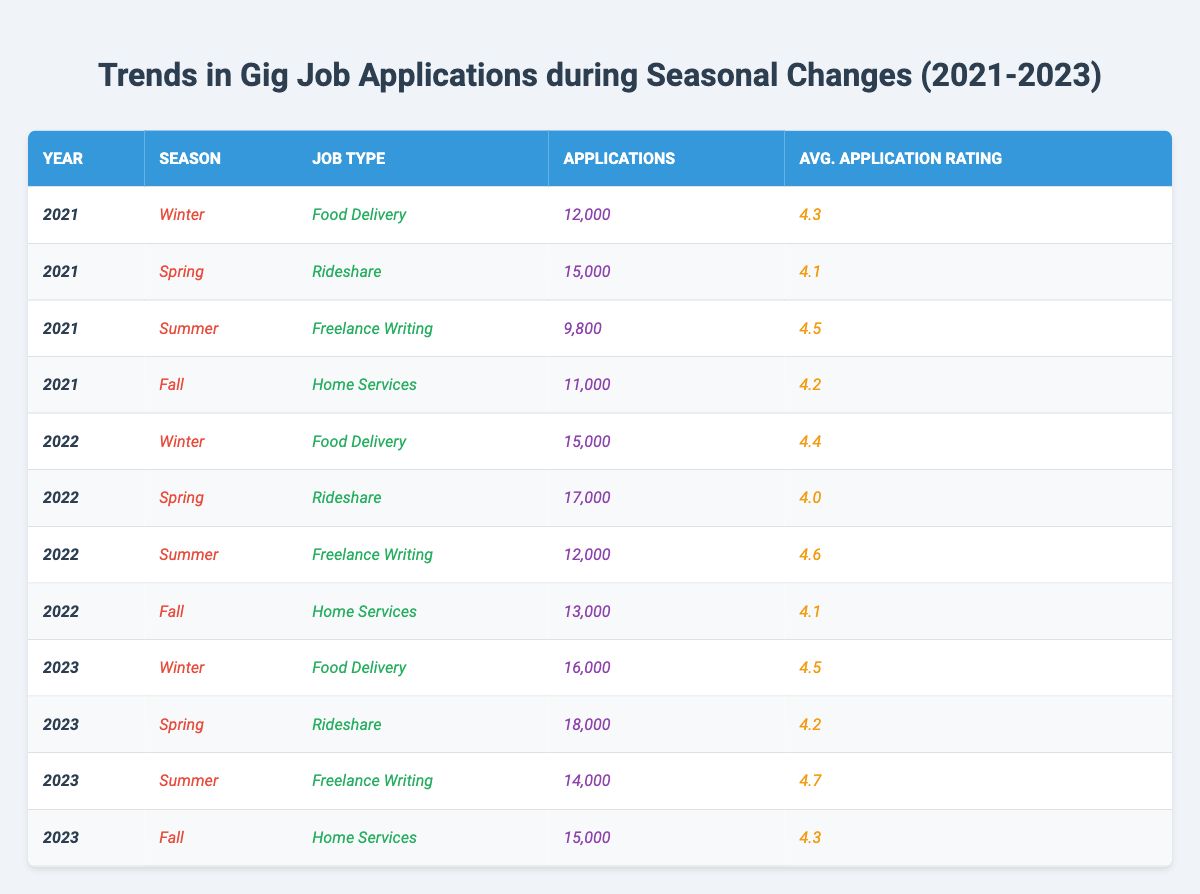What was the highest number of applications for Food Delivery job type across the years? In the table, the number of applications for Food Delivery in 2023 is 16,000, which is higher than 15,000 in 2022 and 12,000 in 2021. Therefore, the highest is 16,000 in 2023.
Answer: 16,000 Which season had the lowest applications for Freelance Writing? The table shows that Freelance Writing had the lowest applications in Summer 2021 with 9,800 applications. Other seasons have higher numbers (Summer 2022 with 12,000 and Summer 2023 with 14,000).
Answer: Summer 2021 What is the total number of applications for Rideshare jobs from 2021 to 2023? Summing the applications gives: 15,000 (2021) + 17,000 (2022) + 18,000 (2023) = 50,000 applications in total for Rideshare jobs over three years.
Answer: 50,000 Did the average application rating for Home Services improve from 2021 to 2022? In the table, the average rating for Home Services was 4.2 in 2021 and decreased to 4.1 in 2022, indicating a decline, so the answer is no.
Answer: No What was the average number of applications for each job type in Spring from 2021 to 2023? For Spring, the applications are: Rideshare in 2021 is 15,000, in 2022 is 17,000, and in 2023 is 18,000. The average is (15,000 + 17,000 + 18,000) / 3 = 16,666.67.
Answer: 16,666.67 Which job type had the highest application rating in Summer 2023, and what was the rating? The highest application rating in Summer 2023 was for Freelance Writing with a rating of 4.7. Other job types in Summer 2023 are not higher.
Answer: Freelance Writing; 4.7 Is it true that the applications for Food Delivery jobs increased every year from 2021 to 2023? The applications for Food Delivery increased from 12,000 in 2021 to 15,000 in 2022 and again to 16,000 in 2023, confirming that it increased each year.
Answer: Yes What is the difference in the number of applications for Home Services from Fall 2021 to Fall 2023? Fall 2021 had 11,000 applications for Home Services, and Fall 2023 had 15,000 applications. The difference is 15,000 - 11,000 = 4,000 applications.
Answer: 4,000 For which season and year did the applications drop the most for any job type? The most significant drop in applications occurred from Summer 2021 (9,800) to Summer 2022 (12,000) in Freelance Writing, showing an increase rather than a drop. The largest drop occurred from Spring 2022 to Spring 2023 in Rideshare jobs, which saw a drop from 17,000 to 18,000 applications.
Answer: No significant drops; only increases were observed What was the trend in the average application ratings from Winter 2021 to Winter 2023? The average ratings for Food Delivery were 4.3 in 2021, 4.4 in 2022, and 4.5 in 2023 showing consistent improvement in ratings over three years.
Answer: Improvement observed What was the average number of applications in Winter across the three years? Adding the Winter applications gives: 12,000 (2021) + 15,000 (2022) + 16,000 (2023) = 43,000, and the average is 43,000 / 3 = 14,333.33.
Answer: 14,333.33 